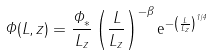<formula> <loc_0><loc_0><loc_500><loc_500>\Phi ( L , z ) = \frac { \Phi _ { * } } { L _ { z } } \left ( \frac { L } { L _ { z } } \right ) ^ { - \beta } { \mathrm e } ^ { - \left ( \frac { L } { L _ { z } } \right ) ^ { 1 / 4 } }</formula> 